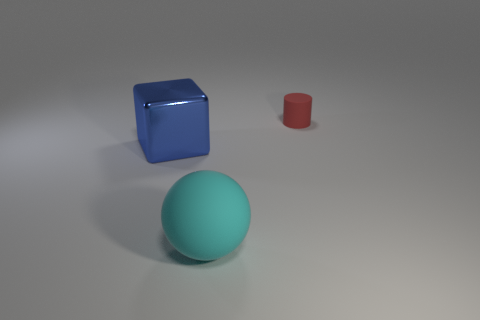Add 2 large red matte cylinders. How many objects exist? 5 Subtract all cylinders. How many objects are left? 2 Subtract 0 brown cubes. How many objects are left? 3 Subtract all tiny rubber balls. Subtract all large matte things. How many objects are left? 2 Add 3 blocks. How many blocks are left? 4 Add 2 big blue things. How many big blue things exist? 3 